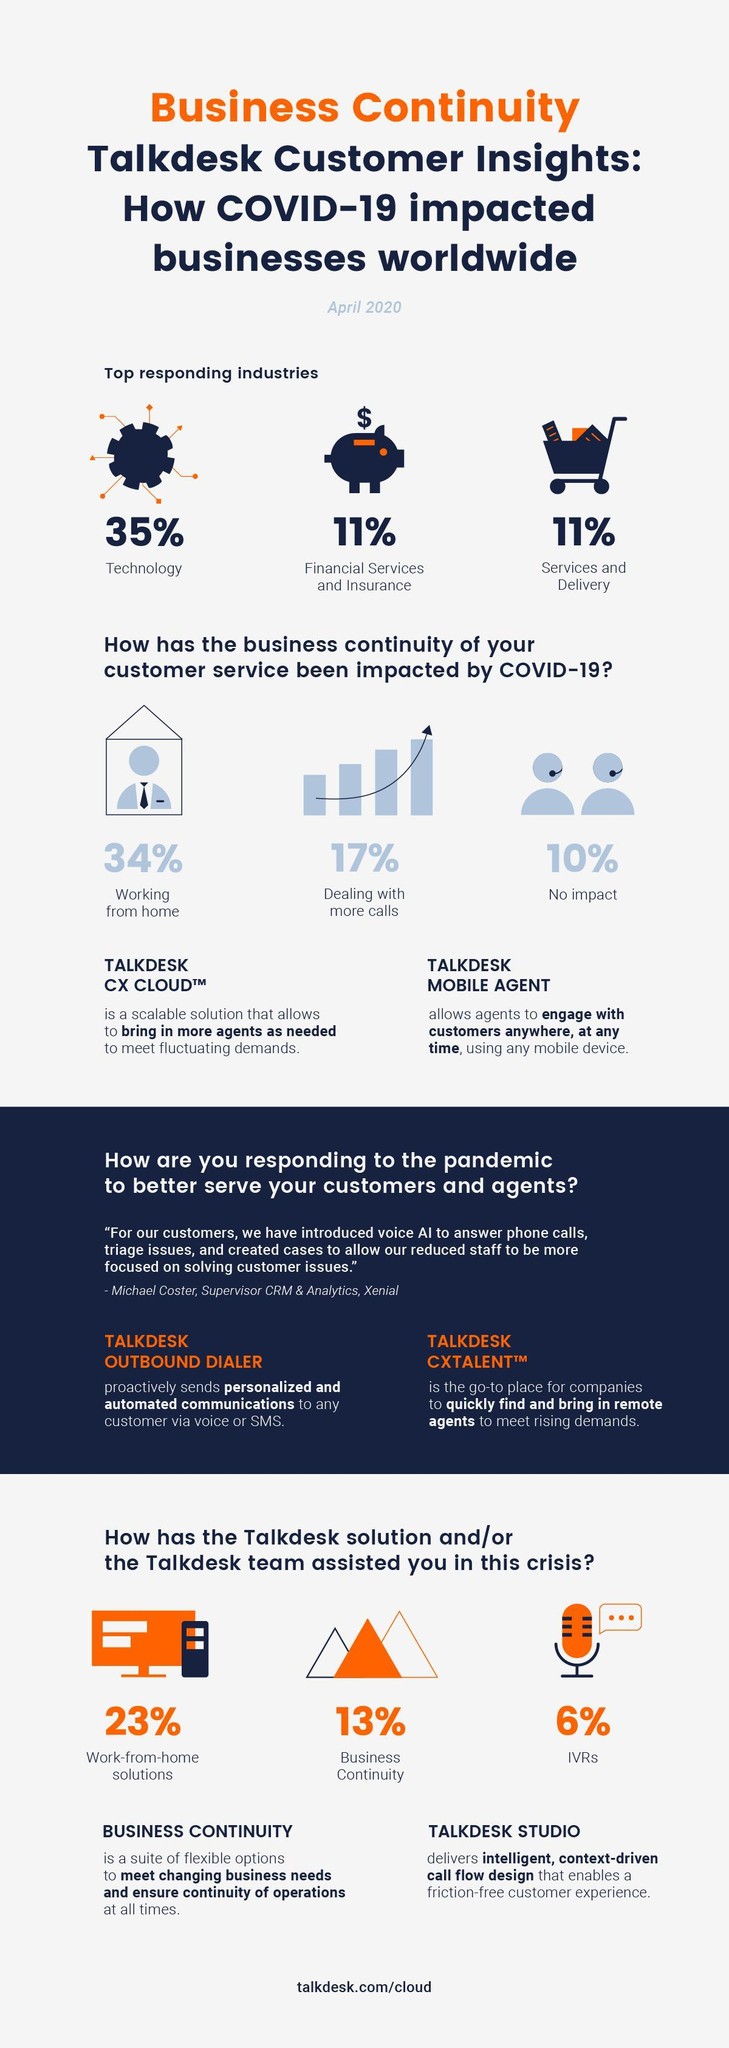what percentage of business continuity of customer service has been impacted?
Answer the question with a short phrase. 90% what is the color combination in which the main heading is written - black and blue or blue and orange? blue and orange which industry has been represented with a cart symbol in this infographic? services and delivery what are the top responding industries? technology, financial services and insurance, services and delivery what percentage of employees are not working from home? 66% 